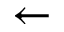Convert formula to latex. <formula><loc_0><loc_0><loc_500><loc_500>\leftarrow</formula> 